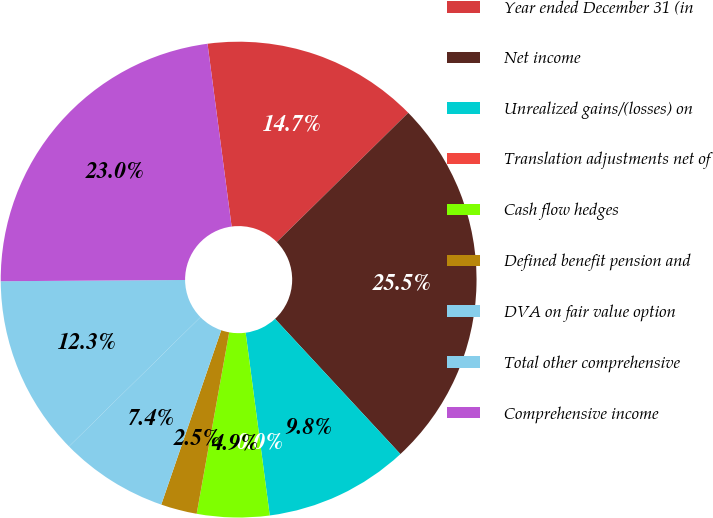Convert chart to OTSL. <chart><loc_0><loc_0><loc_500><loc_500><pie_chart><fcel>Year ended December 31 (in<fcel>Net income<fcel>Unrealized gains/(losses) on<fcel>Translation adjustments net of<fcel>Cash flow hedges<fcel>Defined benefit pension and<fcel>DVA on fair value option<fcel>Total other comprehensive<fcel>Comprehensive income<nl><fcel>14.72%<fcel>25.47%<fcel>9.81%<fcel>0.0%<fcel>4.91%<fcel>2.45%<fcel>7.36%<fcel>12.26%<fcel>23.02%<nl></chart> 